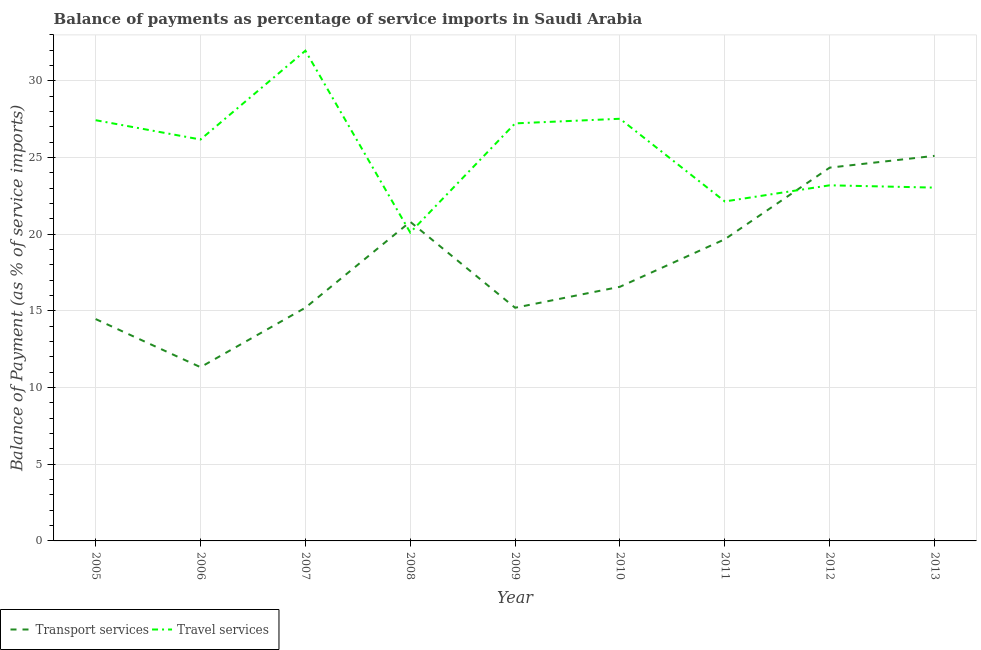Does the line corresponding to balance of payments of travel services intersect with the line corresponding to balance of payments of transport services?
Offer a terse response. Yes. Is the number of lines equal to the number of legend labels?
Provide a succinct answer. Yes. What is the balance of payments of transport services in 2010?
Your answer should be very brief. 16.57. Across all years, what is the maximum balance of payments of transport services?
Give a very brief answer. 25.11. Across all years, what is the minimum balance of payments of transport services?
Provide a short and direct response. 11.33. In which year was the balance of payments of travel services minimum?
Keep it short and to the point. 2008. What is the total balance of payments of travel services in the graph?
Offer a terse response. 228.82. What is the difference between the balance of payments of travel services in 2009 and that in 2012?
Make the answer very short. 4.04. What is the difference between the balance of payments of transport services in 2010 and the balance of payments of travel services in 2009?
Ensure brevity in your answer.  -10.66. What is the average balance of payments of transport services per year?
Offer a very short reply. 18.08. In the year 2012, what is the difference between the balance of payments of transport services and balance of payments of travel services?
Give a very brief answer. 1.15. What is the ratio of the balance of payments of travel services in 2005 to that in 2006?
Keep it short and to the point. 1.05. Is the balance of payments of travel services in 2010 less than that in 2011?
Provide a short and direct response. No. Is the difference between the balance of payments of transport services in 2008 and 2012 greater than the difference between the balance of payments of travel services in 2008 and 2012?
Keep it short and to the point. No. What is the difference between the highest and the second highest balance of payments of transport services?
Your response must be concise. 0.77. What is the difference between the highest and the lowest balance of payments of transport services?
Keep it short and to the point. 13.78. In how many years, is the balance of payments of travel services greater than the average balance of payments of travel services taken over all years?
Ensure brevity in your answer.  5. Is the sum of the balance of payments of transport services in 2009 and 2012 greater than the maximum balance of payments of travel services across all years?
Give a very brief answer. Yes. Does the balance of payments of transport services monotonically increase over the years?
Your response must be concise. No. Is the balance of payments of transport services strictly greater than the balance of payments of travel services over the years?
Your answer should be compact. No. How many lines are there?
Keep it short and to the point. 2. What is the difference between two consecutive major ticks on the Y-axis?
Ensure brevity in your answer.  5. Are the values on the major ticks of Y-axis written in scientific E-notation?
Your response must be concise. No. Does the graph contain any zero values?
Your response must be concise. No. Where does the legend appear in the graph?
Ensure brevity in your answer.  Bottom left. How many legend labels are there?
Your answer should be very brief. 2. What is the title of the graph?
Provide a succinct answer. Balance of payments as percentage of service imports in Saudi Arabia. What is the label or title of the X-axis?
Provide a short and direct response. Year. What is the label or title of the Y-axis?
Make the answer very short. Balance of Payment (as % of service imports). What is the Balance of Payment (as % of service imports) in Transport services in 2005?
Ensure brevity in your answer.  14.47. What is the Balance of Payment (as % of service imports) in Travel services in 2005?
Keep it short and to the point. 27.44. What is the Balance of Payment (as % of service imports) of Transport services in 2006?
Your answer should be compact. 11.33. What is the Balance of Payment (as % of service imports) in Travel services in 2006?
Give a very brief answer. 26.18. What is the Balance of Payment (as % of service imports) in Transport services in 2007?
Your answer should be compact. 15.21. What is the Balance of Payment (as % of service imports) of Travel services in 2007?
Keep it short and to the point. 31.97. What is the Balance of Payment (as % of service imports) in Transport services in 2008?
Provide a short and direct response. 20.81. What is the Balance of Payment (as % of service imports) in Travel services in 2008?
Provide a succinct answer. 20.11. What is the Balance of Payment (as % of service imports) of Transport services in 2009?
Provide a succinct answer. 15.21. What is the Balance of Payment (as % of service imports) in Travel services in 2009?
Give a very brief answer. 27.23. What is the Balance of Payment (as % of service imports) in Transport services in 2010?
Your response must be concise. 16.57. What is the Balance of Payment (as % of service imports) in Travel services in 2010?
Offer a very short reply. 27.53. What is the Balance of Payment (as % of service imports) of Transport services in 2011?
Keep it short and to the point. 19.67. What is the Balance of Payment (as % of service imports) in Travel services in 2011?
Your response must be concise. 22.14. What is the Balance of Payment (as % of service imports) of Transport services in 2012?
Give a very brief answer. 24.34. What is the Balance of Payment (as % of service imports) in Travel services in 2012?
Your answer should be compact. 23.19. What is the Balance of Payment (as % of service imports) in Transport services in 2013?
Offer a terse response. 25.11. What is the Balance of Payment (as % of service imports) of Travel services in 2013?
Your answer should be compact. 23.04. Across all years, what is the maximum Balance of Payment (as % of service imports) of Transport services?
Provide a succinct answer. 25.11. Across all years, what is the maximum Balance of Payment (as % of service imports) of Travel services?
Keep it short and to the point. 31.97. Across all years, what is the minimum Balance of Payment (as % of service imports) of Transport services?
Offer a very short reply. 11.33. Across all years, what is the minimum Balance of Payment (as % of service imports) of Travel services?
Keep it short and to the point. 20.11. What is the total Balance of Payment (as % of service imports) in Transport services in the graph?
Offer a terse response. 162.72. What is the total Balance of Payment (as % of service imports) in Travel services in the graph?
Give a very brief answer. 228.82. What is the difference between the Balance of Payment (as % of service imports) of Transport services in 2005 and that in 2006?
Your answer should be very brief. 3.14. What is the difference between the Balance of Payment (as % of service imports) in Travel services in 2005 and that in 2006?
Keep it short and to the point. 1.26. What is the difference between the Balance of Payment (as % of service imports) of Transport services in 2005 and that in 2007?
Give a very brief answer. -0.74. What is the difference between the Balance of Payment (as % of service imports) in Travel services in 2005 and that in 2007?
Keep it short and to the point. -4.53. What is the difference between the Balance of Payment (as % of service imports) of Transport services in 2005 and that in 2008?
Your response must be concise. -6.34. What is the difference between the Balance of Payment (as % of service imports) in Travel services in 2005 and that in 2008?
Ensure brevity in your answer.  7.33. What is the difference between the Balance of Payment (as % of service imports) of Transport services in 2005 and that in 2009?
Your response must be concise. -0.74. What is the difference between the Balance of Payment (as % of service imports) in Travel services in 2005 and that in 2009?
Provide a short and direct response. 0.21. What is the difference between the Balance of Payment (as % of service imports) of Transport services in 2005 and that in 2010?
Your response must be concise. -2.11. What is the difference between the Balance of Payment (as % of service imports) in Travel services in 2005 and that in 2010?
Provide a short and direct response. -0.09. What is the difference between the Balance of Payment (as % of service imports) in Transport services in 2005 and that in 2011?
Your response must be concise. -5.2. What is the difference between the Balance of Payment (as % of service imports) in Travel services in 2005 and that in 2011?
Provide a succinct answer. 5.3. What is the difference between the Balance of Payment (as % of service imports) of Transport services in 2005 and that in 2012?
Provide a short and direct response. -9.88. What is the difference between the Balance of Payment (as % of service imports) in Travel services in 2005 and that in 2012?
Your response must be concise. 4.25. What is the difference between the Balance of Payment (as % of service imports) in Transport services in 2005 and that in 2013?
Your answer should be very brief. -10.64. What is the difference between the Balance of Payment (as % of service imports) in Travel services in 2005 and that in 2013?
Make the answer very short. 4.4. What is the difference between the Balance of Payment (as % of service imports) in Transport services in 2006 and that in 2007?
Ensure brevity in your answer.  -3.88. What is the difference between the Balance of Payment (as % of service imports) in Travel services in 2006 and that in 2007?
Give a very brief answer. -5.79. What is the difference between the Balance of Payment (as % of service imports) in Transport services in 2006 and that in 2008?
Offer a terse response. -9.48. What is the difference between the Balance of Payment (as % of service imports) of Travel services in 2006 and that in 2008?
Your response must be concise. 6.07. What is the difference between the Balance of Payment (as % of service imports) in Transport services in 2006 and that in 2009?
Keep it short and to the point. -3.88. What is the difference between the Balance of Payment (as % of service imports) of Travel services in 2006 and that in 2009?
Offer a terse response. -1.05. What is the difference between the Balance of Payment (as % of service imports) of Transport services in 2006 and that in 2010?
Provide a succinct answer. -5.24. What is the difference between the Balance of Payment (as % of service imports) of Travel services in 2006 and that in 2010?
Provide a succinct answer. -1.35. What is the difference between the Balance of Payment (as % of service imports) in Transport services in 2006 and that in 2011?
Provide a succinct answer. -8.34. What is the difference between the Balance of Payment (as % of service imports) in Travel services in 2006 and that in 2011?
Provide a short and direct response. 4.04. What is the difference between the Balance of Payment (as % of service imports) in Transport services in 2006 and that in 2012?
Keep it short and to the point. -13.01. What is the difference between the Balance of Payment (as % of service imports) of Travel services in 2006 and that in 2012?
Keep it short and to the point. 2.99. What is the difference between the Balance of Payment (as % of service imports) in Transport services in 2006 and that in 2013?
Keep it short and to the point. -13.78. What is the difference between the Balance of Payment (as % of service imports) of Travel services in 2006 and that in 2013?
Offer a terse response. 3.14. What is the difference between the Balance of Payment (as % of service imports) in Transport services in 2007 and that in 2008?
Provide a succinct answer. -5.6. What is the difference between the Balance of Payment (as % of service imports) in Travel services in 2007 and that in 2008?
Keep it short and to the point. 11.86. What is the difference between the Balance of Payment (as % of service imports) of Transport services in 2007 and that in 2009?
Offer a very short reply. 0. What is the difference between the Balance of Payment (as % of service imports) of Travel services in 2007 and that in 2009?
Give a very brief answer. 4.74. What is the difference between the Balance of Payment (as % of service imports) in Transport services in 2007 and that in 2010?
Provide a short and direct response. -1.37. What is the difference between the Balance of Payment (as % of service imports) of Travel services in 2007 and that in 2010?
Offer a terse response. 4.44. What is the difference between the Balance of Payment (as % of service imports) of Transport services in 2007 and that in 2011?
Offer a terse response. -4.46. What is the difference between the Balance of Payment (as % of service imports) in Travel services in 2007 and that in 2011?
Give a very brief answer. 9.83. What is the difference between the Balance of Payment (as % of service imports) of Transport services in 2007 and that in 2012?
Give a very brief answer. -9.13. What is the difference between the Balance of Payment (as % of service imports) of Travel services in 2007 and that in 2012?
Your answer should be very brief. 8.78. What is the difference between the Balance of Payment (as % of service imports) of Transport services in 2007 and that in 2013?
Ensure brevity in your answer.  -9.9. What is the difference between the Balance of Payment (as % of service imports) of Travel services in 2007 and that in 2013?
Offer a very short reply. 8.93. What is the difference between the Balance of Payment (as % of service imports) of Transport services in 2008 and that in 2009?
Your answer should be very brief. 5.6. What is the difference between the Balance of Payment (as % of service imports) in Travel services in 2008 and that in 2009?
Offer a terse response. -7.12. What is the difference between the Balance of Payment (as % of service imports) of Transport services in 2008 and that in 2010?
Your answer should be very brief. 4.24. What is the difference between the Balance of Payment (as % of service imports) of Travel services in 2008 and that in 2010?
Make the answer very short. -7.42. What is the difference between the Balance of Payment (as % of service imports) of Transport services in 2008 and that in 2011?
Offer a terse response. 1.14. What is the difference between the Balance of Payment (as % of service imports) in Travel services in 2008 and that in 2011?
Offer a terse response. -2.03. What is the difference between the Balance of Payment (as % of service imports) in Transport services in 2008 and that in 2012?
Make the answer very short. -3.53. What is the difference between the Balance of Payment (as % of service imports) of Travel services in 2008 and that in 2012?
Ensure brevity in your answer.  -3.08. What is the difference between the Balance of Payment (as % of service imports) of Transport services in 2008 and that in 2013?
Your response must be concise. -4.3. What is the difference between the Balance of Payment (as % of service imports) of Travel services in 2008 and that in 2013?
Provide a short and direct response. -2.93. What is the difference between the Balance of Payment (as % of service imports) in Transport services in 2009 and that in 2010?
Ensure brevity in your answer.  -1.37. What is the difference between the Balance of Payment (as % of service imports) in Travel services in 2009 and that in 2010?
Your answer should be very brief. -0.3. What is the difference between the Balance of Payment (as % of service imports) of Transport services in 2009 and that in 2011?
Offer a very short reply. -4.47. What is the difference between the Balance of Payment (as % of service imports) in Travel services in 2009 and that in 2011?
Offer a very short reply. 5.09. What is the difference between the Balance of Payment (as % of service imports) of Transport services in 2009 and that in 2012?
Your answer should be compact. -9.14. What is the difference between the Balance of Payment (as % of service imports) in Travel services in 2009 and that in 2012?
Offer a terse response. 4.04. What is the difference between the Balance of Payment (as % of service imports) of Transport services in 2009 and that in 2013?
Provide a succinct answer. -9.91. What is the difference between the Balance of Payment (as % of service imports) in Travel services in 2009 and that in 2013?
Provide a succinct answer. 4.19. What is the difference between the Balance of Payment (as % of service imports) in Transport services in 2010 and that in 2011?
Your answer should be very brief. -3.1. What is the difference between the Balance of Payment (as % of service imports) in Travel services in 2010 and that in 2011?
Keep it short and to the point. 5.39. What is the difference between the Balance of Payment (as % of service imports) in Transport services in 2010 and that in 2012?
Keep it short and to the point. -7.77. What is the difference between the Balance of Payment (as % of service imports) of Travel services in 2010 and that in 2012?
Provide a short and direct response. 4.34. What is the difference between the Balance of Payment (as % of service imports) of Transport services in 2010 and that in 2013?
Offer a terse response. -8.54. What is the difference between the Balance of Payment (as % of service imports) of Travel services in 2010 and that in 2013?
Keep it short and to the point. 4.49. What is the difference between the Balance of Payment (as % of service imports) in Transport services in 2011 and that in 2012?
Give a very brief answer. -4.67. What is the difference between the Balance of Payment (as % of service imports) of Travel services in 2011 and that in 2012?
Keep it short and to the point. -1.05. What is the difference between the Balance of Payment (as % of service imports) of Transport services in 2011 and that in 2013?
Provide a short and direct response. -5.44. What is the difference between the Balance of Payment (as % of service imports) of Travel services in 2011 and that in 2013?
Provide a succinct answer. -0.9. What is the difference between the Balance of Payment (as % of service imports) of Transport services in 2012 and that in 2013?
Keep it short and to the point. -0.77. What is the difference between the Balance of Payment (as % of service imports) of Travel services in 2012 and that in 2013?
Your response must be concise. 0.15. What is the difference between the Balance of Payment (as % of service imports) in Transport services in 2005 and the Balance of Payment (as % of service imports) in Travel services in 2006?
Offer a very short reply. -11.71. What is the difference between the Balance of Payment (as % of service imports) in Transport services in 2005 and the Balance of Payment (as % of service imports) in Travel services in 2007?
Your answer should be compact. -17.5. What is the difference between the Balance of Payment (as % of service imports) in Transport services in 2005 and the Balance of Payment (as % of service imports) in Travel services in 2008?
Your answer should be compact. -5.64. What is the difference between the Balance of Payment (as % of service imports) of Transport services in 2005 and the Balance of Payment (as % of service imports) of Travel services in 2009?
Offer a terse response. -12.76. What is the difference between the Balance of Payment (as % of service imports) of Transport services in 2005 and the Balance of Payment (as % of service imports) of Travel services in 2010?
Ensure brevity in your answer.  -13.06. What is the difference between the Balance of Payment (as % of service imports) in Transport services in 2005 and the Balance of Payment (as % of service imports) in Travel services in 2011?
Offer a terse response. -7.67. What is the difference between the Balance of Payment (as % of service imports) in Transport services in 2005 and the Balance of Payment (as % of service imports) in Travel services in 2012?
Give a very brief answer. -8.72. What is the difference between the Balance of Payment (as % of service imports) of Transport services in 2005 and the Balance of Payment (as % of service imports) of Travel services in 2013?
Give a very brief answer. -8.57. What is the difference between the Balance of Payment (as % of service imports) in Transport services in 2006 and the Balance of Payment (as % of service imports) in Travel services in 2007?
Make the answer very short. -20.64. What is the difference between the Balance of Payment (as % of service imports) of Transport services in 2006 and the Balance of Payment (as % of service imports) of Travel services in 2008?
Offer a very short reply. -8.78. What is the difference between the Balance of Payment (as % of service imports) in Transport services in 2006 and the Balance of Payment (as % of service imports) in Travel services in 2009?
Offer a terse response. -15.9. What is the difference between the Balance of Payment (as % of service imports) of Transport services in 2006 and the Balance of Payment (as % of service imports) of Travel services in 2010?
Offer a terse response. -16.2. What is the difference between the Balance of Payment (as % of service imports) of Transport services in 2006 and the Balance of Payment (as % of service imports) of Travel services in 2011?
Your answer should be very brief. -10.81. What is the difference between the Balance of Payment (as % of service imports) in Transport services in 2006 and the Balance of Payment (as % of service imports) in Travel services in 2012?
Keep it short and to the point. -11.86. What is the difference between the Balance of Payment (as % of service imports) in Transport services in 2006 and the Balance of Payment (as % of service imports) in Travel services in 2013?
Keep it short and to the point. -11.71. What is the difference between the Balance of Payment (as % of service imports) of Transport services in 2007 and the Balance of Payment (as % of service imports) of Travel services in 2008?
Give a very brief answer. -4.9. What is the difference between the Balance of Payment (as % of service imports) in Transport services in 2007 and the Balance of Payment (as % of service imports) in Travel services in 2009?
Your answer should be very brief. -12.02. What is the difference between the Balance of Payment (as % of service imports) of Transport services in 2007 and the Balance of Payment (as % of service imports) of Travel services in 2010?
Your response must be concise. -12.32. What is the difference between the Balance of Payment (as % of service imports) of Transport services in 2007 and the Balance of Payment (as % of service imports) of Travel services in 2011?
Your answer should be compact. -6.93. What is the difference between the Balance of Payment (as % of service imports) in Transport services in 2007 and the Balance of Payment (as % of service imports) in Travel services in 2012?
Your response must be concise. -7.98. What is the difference between the Balance of Payment (as % of service imports) of Transport services in 2007 and the Balance of Payment (as % of service imports) of Travel services in 2013?
Offer a terse response. -7.83. What is the difference between the Balance of Payment (as % of service imports) in Transport services in 2008 and the Balance of Payment (as % of service imports) in Travel services in 2009?
Your answer should be very brief. -6.42. What is the difference between the Balance of Payment (as % of service imports) of Transport services in 2008 and the Balance of Payment (as % of service imports) of Travel services in 2010?
Offer a terse response. -6.72. What is the difference between the Balance of Payment (as % of service imports) in Transport services in 2008 and the Balance of Payment (as % of service imports) in Travel services in 2011?
Offer a terse response. -1.33. What is the difference between the Balance of Payment (as % of service imports) in Transport services in 2008 and the Balance of Payment (as % of service imports) in Travel services in 2012?
Keep it short and to the point. -2.38. What is the difference between the Balance of Payment (as % of service imports) in Transport services in 2008 and the Balance of Payment (as % of service imports) in Travel services in 2013?
Ensure brevity in your answer.  -2.23. What is the difference between the Balance of Payment (as % of service imports) in Transport services in 2009 and the Balance of Payment (as % of service imports) in Travel services in 2010?
Keep it short and to the point. -12.32. What is the difference between the Balance of Payment (as % of service imports) of Transport services in 2009 and the Balance of Payment (as % of service imports) of Travel services in 2011?
Make the answer very short. -6.93. What is the difference between the Balance of Payment (as % of service imports) of Transport services in 2009 and the Balance of Payment (as % of service imports) of Travel services in 2012?
Provide a short and direct response. -7.99. What is the difference between the Balance of Payment (as % of service imports) in Transport services in 2009 and the Balance of Payment (as % of service imports) in Travel services in 2013?
Provide a short and direct response. -7.83. What is the difference between the Balance of Payment (as % of service imports) in Transport services in 2010 and the Balance of Payment (as % of service imports) in Travel services in 2011?
Offer a terse response. -5.57. What is the difference between the Balance of Payment (as % of service imports) of Transport services in 2010 and the Balance of Payment (as % of service imports) of Travel services in 2012?
Provide a short and direct response. -6.62. What is the difference between the Balance of Payment (as % of service imports) in Transport services in 2010 and the Balance of Payment (as % of service imports) in Travel services in 2013?
Give a very brief answer. -6.47. What is the difference between the Balance of Payment (as % of service imports) in Transport services in 2011 and the Balance of Payment (as % of service imports) in Travel services in 2012?
Keep it short and to the point. -3.52. What is the difference between the Balance of Payment (as % of service imports) of Transport services in 2011 and the Balance of Payment (as % of service imports) of Travel services in 2013?
Give a very brief answer. -3.37. What is the difference between the Balance of Payment (as % of service imports) of Transport services in 2012 and the Balance of Payment (as % of service imports) of Travel services in 2013?
Offer a very short reply. 1.3. What is the average Balance of Payment (as % of service imports) of Transport services per year?
Your answer should be very brief. 18.08. What is the average Balance of Payment (as % of service imports) of Travel services per year?
Provide a short and direct response. 25.42. In the year 2005, what is the difference between the Balance of Payment (as % of service imports) in Transport services and Balance of Payment (as % of service imports) in Travel services?
Offer a terse response. -12.97. In the year 2006, what is the difference between the Balance of Payment (as % of service imports) of Transport services and Balance of Payment (as % of service imports) of Travel services?
Provide a short and direct response. -14.85. In the year 2007, what is the difference between the Balance of Payment (as % of service imports) of Transport services and Balance of Payment (as % of service imports) of Travel services?
Provide a short and direct response. -16.76. In the year 2008, what is the difference between the Balance of Payment (as % of service imports) of Transport services and Balance of Payment (as % of service imports) of Travel services?
Your answer should be very brief. 0.7. In the year 2009, what is the difference between the Balance of Payment (as % of service imports) in Transport services and Balance of Payment (as % of service imports) in Travel services?
Provide a short and direct response. -12.02. In the year 2010, what is the difference between the Balance of Payment (as % of service imports) of Transport services and Balance of Payment (as % of service imports) of Travel services?
Your answer should be compact. -10.96. In the year 2011, what is the difference between the Balance of Payment (as % of service imports) of Transport services and Balance of Payment (as % of service imports) of Travel services?
Provide a short and direct response. -2.47. In the year 2012, what is the difference between the Balance of Payment (as % of service imports) in Transport services and Balance of Payment (as % of service imports) in Travel services?
Your answer should be compact. 1.15. In the year 2013, what is the difference between the Balance of Payment (as % of service imports) of Transport services and Balance of Payment (as % of service imports) of Travel services?
Give a very brief answer. 2.07. What is the ratio of the Balance of Payment (as % of service imports) in Transport services in 2005 to that in 2006?
Make the answer very short. 1.28. What is the ratio of the Balance of Payment (as % of service imports) of Travel services in 2005 to that in 2006?
Your answer should be compact. 1.05. What is the ratio of the Balance of Payment (as % of service imports) in Transport services in 2005 to that in 2007?
Your answer should be compact. 0.95. What is the ratio of the Balance of Payment (as % of service imports) in Travel services in 2005 to that in 2007?
Provide a short and direct response. 0.86. What is the ratio of the Balance of Payment (as % of service imports) in Transport services in 2005 to that in 2008?
Offer a terse response. 0.7. What is the ratio of the Balance of Payment (as % of service imports) in Travel services in 2005 to that in 2008?
Keep it short and to the point. 1.36. What is the ratio of the Balance of Payment (as % of service imports) in Transport services in 2005 to that in 2009?
Offer a very short reply. 0.95. What is the ratio of the Balance of Payment (as % of service imports) in Travel services in 2005 to that in 2009?
Your response must be concise. 1.01. What is the ratio of the Balance of Payment (as % of service imports) in Transport services in 2005 to that in 2010?
Offer a very short reply. 0.87. What is the ratio of the Balance of Payment (as % of service imports) of Transport services in 2005 to that in 2011?
Your answer should be compact. 0.74. What is the ratio of the Balance of Payment (as % of service imports) in Travel services in 2005 to that in 2011?
Ensure brevity in your answer.  1.24. What is the ratio of the Balance of Payment (as % of service imports) in Transport services in 2005 to that in 2012?
Give a very brief answer. 0.59. What is the ratio of the Balance of Payment (as % of service imports) in Travel services in 2005 to that in 2012?
Offer a very short reply. 1.18. What is the ratio of the Balance of Payment (as % of service imports) of Transport services in 2005 to that in 2013?
Your answer should be compact. 0.58. What is the ratio of the Balance of Payment (as % of service imports) in Travel services in 2005 to that in 2013?
Your answer should be compact. 1.19. What is the ratio of the Balance of Payment (as % of service imports) of Transport services in 2006 to that in 2007?
Ensure brevity in your answer.  0.74. What is the ratio of the Balance of Payment (as % of service imports) of Travel services in 2006 to that in 2007?
Keep it short and to the point. 0.82. What is the ratio of the Balance of Payment (as % of service imports) of Transport services in 2006 to that in 2008?
Your response must be concise. 0.54. What is the ratio of the Balance of Payment (as % of service imports) in Travel services in 2006 to that in 2008?
Offer a very short reply. 1.3. What is the ratio of the Balance of Payment (as % of service imports) of Transport services in 2006 to that in 2009?
Your answer should be very brief. 0.75. What is the ratio of the Balance of Payment (as % of service imports) in Travel services in 2006 to that in 2009?
Offer a terse response. 0.96. What is the ratio of the Balance of Payment (as % of service imports) in Transport services in 2006 to that in 2010?
Provide a succinct answer. 0.68. What is the ratio of the Balance of Payment (as % of service imports) in Travel services in 2006 to that in 2010?
Give a very brief answer. 0.95. What is the ratio of the Balance of Payment (as % of service imports) of Transport services in 2006 to that in 2011?
Give a very brief answer. 0.58. What is the ratio of the Balance of Payment (as % of service imports) in Travel services in 2006 to that in 2011?
Provide a short and direct response. 1.18. What is the ratio of the Balance of Payment (as % of service imports) in Transport services in 2006 to that in 2012?
Your answer should be compact. 0.47. What is the ratio of the Balance of Payment (as % of service imports) in Travel services in 2006 to that in 2012?
Provide a short and direct response. 1.13. What is the ratio of the Balance of Payment (as % of service imports) of Transport services in 2006 to that in 2013?
Ensure brevity in your answer.  0.45. What is the ratio of the Balance of Payment (as % of service imports) of Travel services in 2006 to that in 2013?
Give a very brief answer. 1.14. What is the ratio of the Balance of Payment (as % of service imports) in Transport services in 2007 to that in 2008?
Offer a very short reply. 0.73. What is the ratio of the Balance of Payment (as % of service imports) of Travel services in 2007 to that in 2008?
Offer a very short reply. 1.59. What is the ratio of the Balance of Payment (as % of service imports) in Transport services in 2007 to that in 2009?
Keep it short and to the point. 1. What is the ratio of the Balance of Payment (as % of service imports) of Travel services in 2007 to that in 2009?
Ensure brevity in your answer.  1.17. What is the ratio of the Balance of Payment (as % of service imports) of Transport services in 2007 to that in 2010?
Give a very brief answer. 0.92. What is the ratio of the Balance of Payment (as % of service imports) of Travel services in 2007 to that in 2010?
Your answer should be very brief. 1.16. What is the ratio of the Balance of Payment (as % of service imports) of Transport services in 2007 to that in 2011?
Your response must be concise. 0.77. What is the ratio of the Balance of Payment (as % of service imports) of Travel services in 2007 to that in 2011?
Your answer should be compact. 1.44. What is the ratio of the Balance of Payment (as % of service imports) of Transport services in 2007 to that in 2012?
Provide a succinct answer. 0.62. What is the ratio of the Balance of Payment (as % of service imports) in Travel services in 2007 to that in 2012?
Give a very brief answer. 1.38. What is the ratio of the Balance of Payment (as % of service imports) in Transport services in 2007 to that in 2013?
Keep it short and to the point. 0.61. What is the ratio of the Balance of Payment (as % of service imports) of Travel services in 2007 to that in 2013?
Make the answer very short. 1.39. What is the ratio of the Balance of Payment (as % of service imports) in Transport services in 2008 to that in 2009?
Provide a short and direct response. 1.37. What is the ratio of the Balance of Payment (as % of service imports) in Travel services in 2008 to that in 2009?
Provide a succinct answer. 0.74. What is the ratio of the Balance of Payment (as % of service imports) in Transport services in 2008 to that in 2010?
Your answer should be very brief. 1.26. What is the ratio of the Balance of Payment (as % of service imports) of Travel services in 2008 to that in 2010?
Your answer should be compact. 0.73. What is the ratio of the Balance of Payment (as % of service imports) in Transport services in 2008 to that in 2011?
Your answer should be very brief. 1.06. What is the ratio of the Balance of Payment (as % of service imports) in Travel services in 2008 to that in 2011?
Your response must be concise. 0.91. What is the ratio of the Balance of Payment (as % of service imports) in Transport services in 2008 to that in 2012?
Offer a very short reply. 0.85. What is the ratio of the Balance of Payment (as % of service imports) in Travel services in 2008 to that in 2012?
Ensure brevity in your answer.  0.87. What is the ratio of the Balance of Payment (as % of service imports) of Transport services in 2008 to that in 2013?
Your answer should be very brief. 0.83. What is the ratio of the Balance of Payment (as % of service imports) in Travel services in 2008 to that in 2013?
Provide a succinct answer. 0.87. What is the ratio of the Balance of Payment (as % of service imports) in Transport services in 2009 to that in 2010?
Make the answer very short. 0.92. What is the ratio of the Balance of Payment (as % of service imports) in Travel services in 2009 to that in 2010?
Provide a short and direct response. 0.99. What is the ratio of the Balance of Payment (as % of service imports) of Transport services in 2009 to that in 2011?
Make the answer very short. 0.77. What is the ratio of the Balance of Payment (as % of service imports) of Travel services in 2009 to that in 2011?
Keep it short and to the point. 1.23. What is the ratio of the Balance of Payment (as % of service imports) of Transport services in 2009 to that in 2012?
Keep it short and to the point. 0.62. What is the ratio of the Balance of Payment (as % of service imports) of Travel services in 2009 to that in 2012?
Ensure brevity in your answer.  1.17. What is the ratio of the Balance of Payment (as % of service imports) of Transport services in 2009 to that in 2013?
Ensure brevity in your answer.  0.61. What is the ratio of the Balance of Payment (as % of service imports) of Travel services in 2009 to that in 2013?
Your answer should be very brief. 1.18. What is the ratio of the Balance of Payment (as % of service imports) in Transport services in 2010 to that in 2011?
Ensure brevity in your answer.  0.84. What is the ratio of the Balance of Payment (as % of service imports) of Travel services in 2010 to that in 2011?
Make the answer very short. 1.24. What is the ratio of the Balance of Payment (as % of service imports) of Transport services in 2010 to that in 2012?
Make the answer very short. 0.68. What is the ratio of the Balance of Payment (as % of service imports) of Travel services in 2010 to that in 2012?
Your answer should be very brief. 1.19. What is the ratio of the Balance of Payment (as % of service imports) of Transport services in 2010 to that in 2013?
Provide a succinct answer. 0.66. What is the ratio of the Balance of Payment (as % of service imports) in Travel services in 2010 to that in 2013?
Your answer should be compact. 1.19. What is the ratio of the Balance of Payment (as % of service imports) in Transport services in 2011 to that in 2012?
Provide a short and direct response. 0.81. What is the ratio of the Balance of Payment (as % of service imports) in Travel services in 2011 to that in 2012?
Your answer should be very brief. 0.95. What is the ratio of the Balance of Payment (as % of service imports) of Transport services in 2011 to that in 2013?
Give a very brief answer. 0.78. What is the ratio of the Balance of Payment (as % of service imports) of Travel services in 2011 to that in 2013?
Your answer should be compact. 0.96. What is the ratio of the Balance of Payment (as % of service imports) in Transport services in 2012 to that in 2013?
Offer a terse response. 0.97. What is the ratio of the Balance of Payment (as % of service imports) in Travel services in 2012 to that in 2013?
Provide a succinct answer. 1.01. What is the difference between the highest and the second highest Balance of Payment (as % of service imports) of Transport services?
Ensure brevity in your answer.  0.77. What is the difference between the highest and the second highest Balance of Payment (as % of service imports) of Travel services?
Your answer should be compact. 4.44. What is the difference between the highest and the lowest Balance of Payment (as % of service imports) of Transport services?
Your response must be concise. 13.78. What is the difference between the highest and the lowest Balance of Payment (as % of service imports) of Travel services?
Keep it short and to the point. 11.86. 